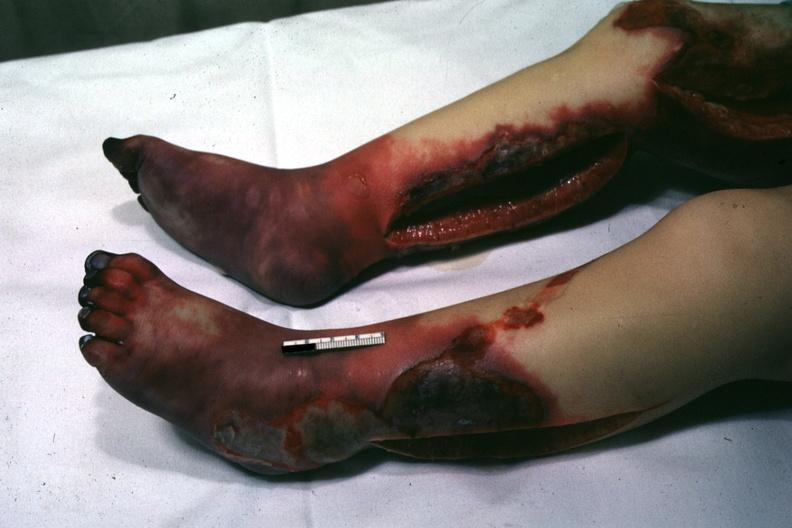does this image show horrible example of gangrene of feet and skin of legs with pseudomonas sepsis?
Answer the question using a single word or phrase. Yes 